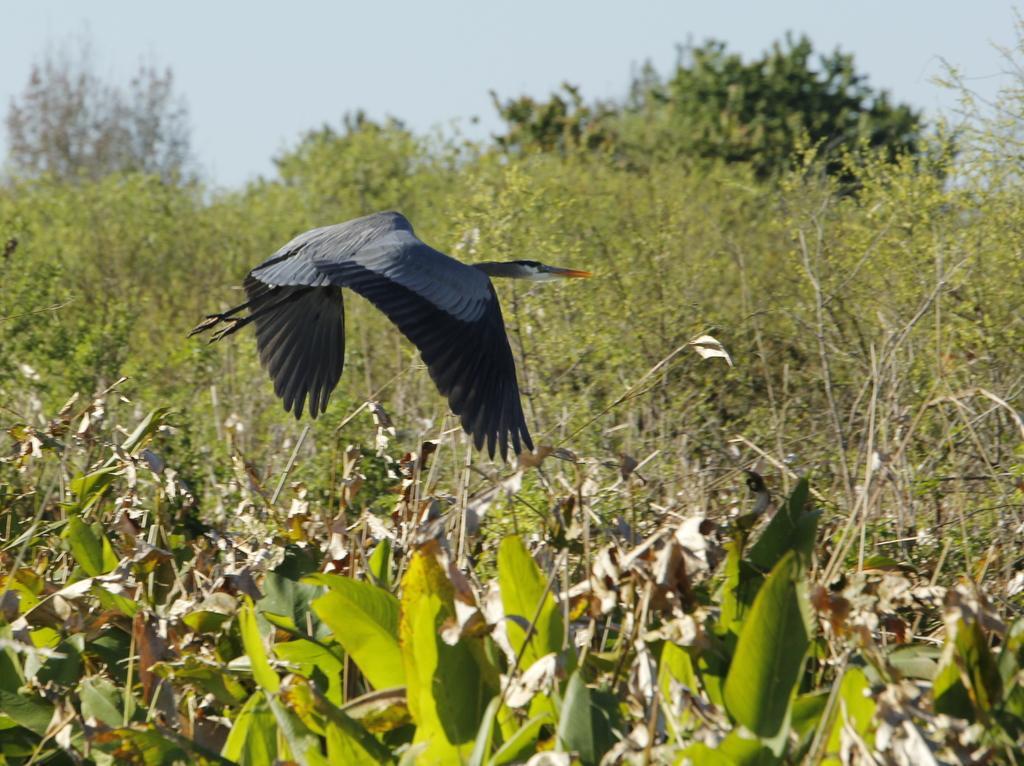In one or two sentences, can you explain what this image depicts? At the bottom of the image we can see some plants. In the middle of the image a bird is flying. Behind the bird we can see some trees. At the top of the image we can see the sky. 